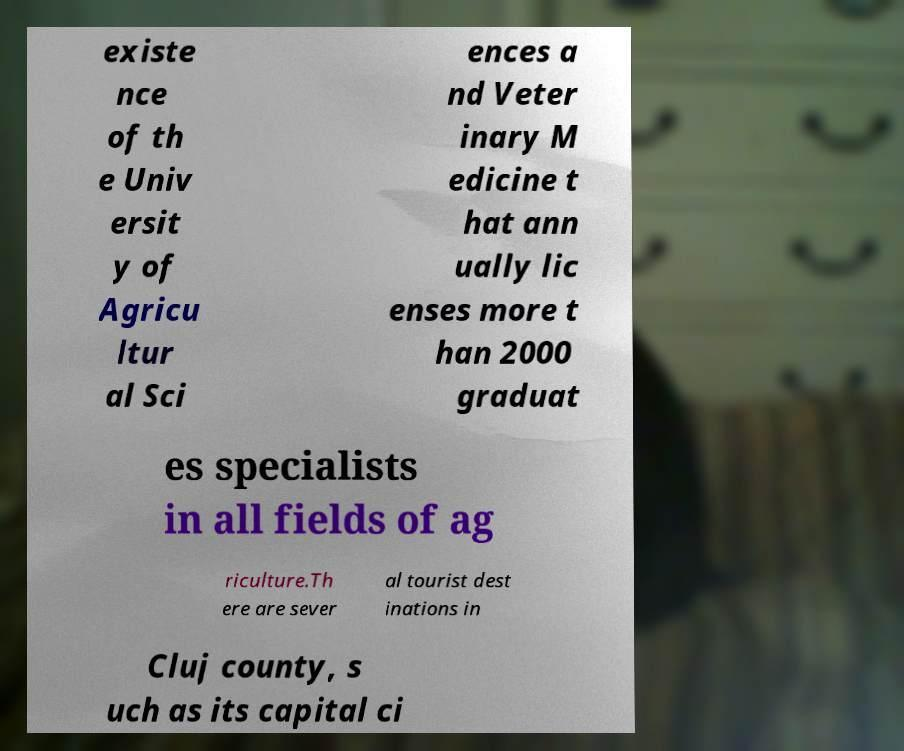There's text embedded in this image that I need extracted. Can you transcribe it verbatim? existe nce of th e Univ ersit y of Agricu ltur al Sci ences a nd Veter inary M edicine t hat ann ually lic enses more t han 2000 graduat es specialists in all fields of ag riculture.Th ere are sever al tourist dest inations in Cluj county, s uch as its capital ci 